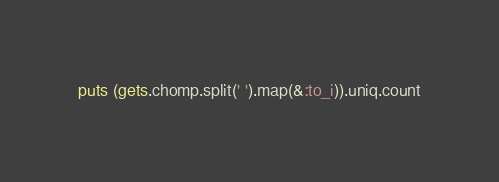Convert code to text. <code><loc_0><loc_0><loc_500><loc_500><_Ruby_>puts (gets.chomp.split(' ').map(&:to_i)).uniq.count</code> 